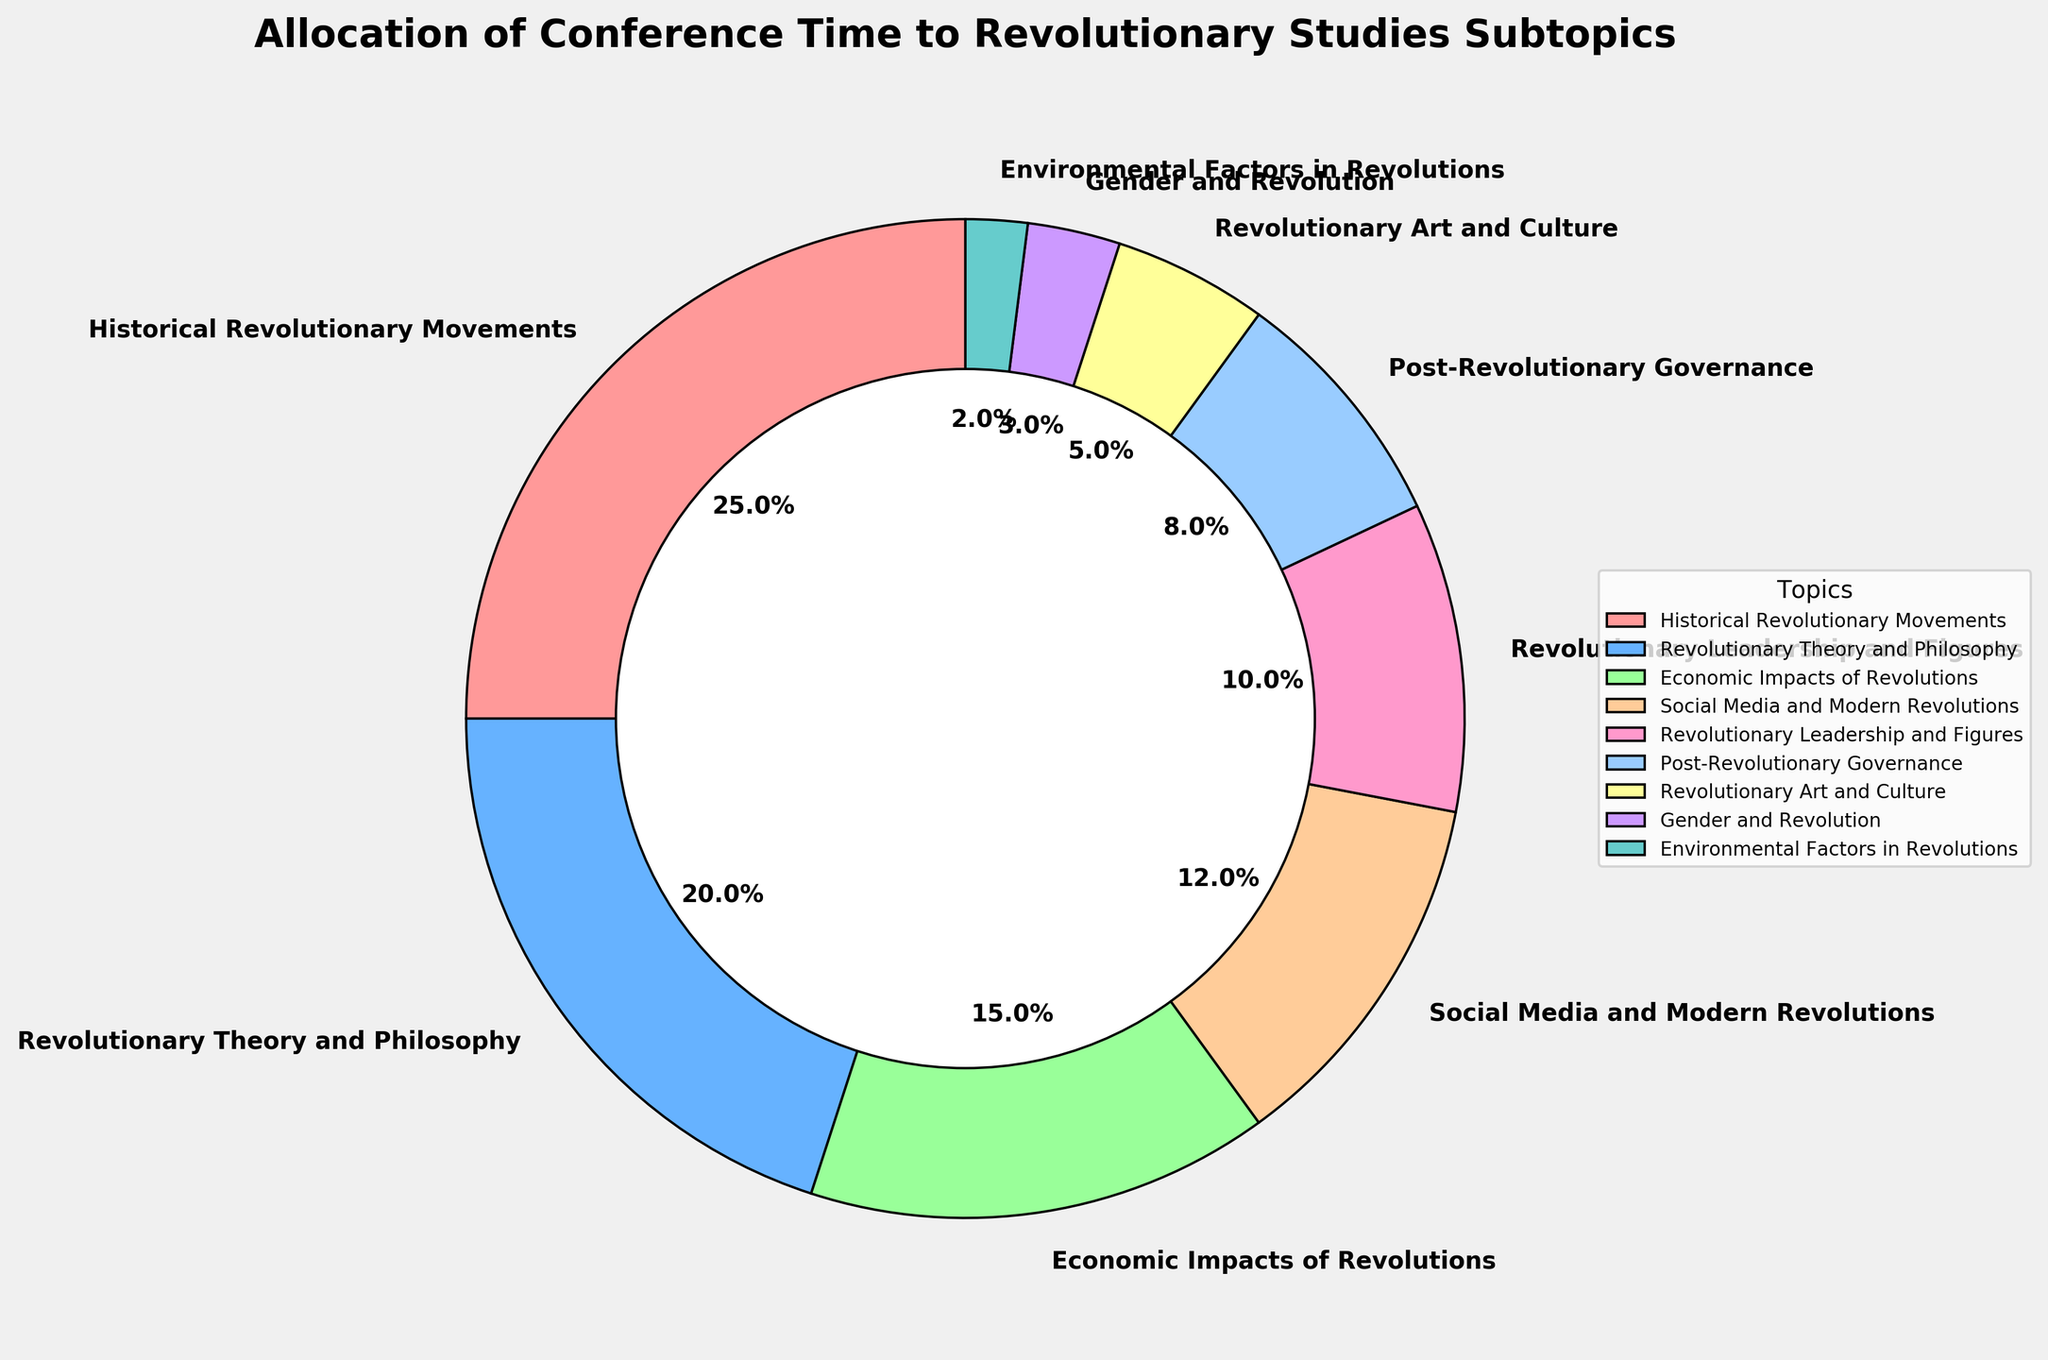what is the total percentage allocated to Historical Revolutionary Movements and Revolutionary Theory and Philosophy, combined? Add the percentages for Historical Revolutionary Movements (25%) and Revolutionary Theory and Philosophy (20%): 25 + 20 = 45
Answer: 45 Which subtopic receives the least amount of time in the conference's schedule? The smallest slice in the pie chart corresponds to Environmental Factors in Revolutions with 2%
Answer: Environmental Factors in Revolutions How does the time allocated to Economic Impacts of Revolutions compare to that for Revolutionary Leadership and Figures? The pie chart shows that Economic Impacts of Revolutions get 15%, and Revolutionary Leadership and Figures get 10%. Thus, Economic Impacts of Revolutions has 5% more time allocated (15 - 10 = 5)
Answer: Economic Impacts of Revolutions has 5% more What is the midpoint value of the percentages allocated to Post-Revolutionary Governance, Revolutionary Art and Culture, and Economic Impacts of Revolutions? First, sum the percentage values: 8 (Post-Revolutionary Governance) + 5 (Revolutionary Art and Culture) + 15 (Economic Impacts of Revolutions) = 28. Then divide by 3 for the average: 28 / 3 ≈ 9.33
Answer: 9.33 Which subtopics combined make up more than half (50%) of the conference's schedule? Combine the highest percentage subtopics until their total exceeds 50%. Adding Historical Revolutionary Movements (25%), Revolutionary Theory and Philosophy (20%), and Economic Impacts of Revolutions (15%) gives us a total of 60% (25 + 20 + 15 = 60)
Answer: Historical Revolutionary Movements, Revolutionary Theory and Philosophy, and Economic Impacts of Revolutions What is the difference in percentage allocation between Social Media and Modern Revolutions and Gender and Revolution? Social Media and Modern Revolutions are allocated 12%, and Gender and Revolution is allocated 3%. The difference is: 12 - 3 = 9
Answer: 9 Which subtopic related to leadership has the highest allocation percentage? Among the subtopics related to leadership, Revolutionary Leadership and Figures have the highest allocation at 10%
Answer: Revolutionary Leadership and Figures How much time is allocated to the combination of subtopics focusing on culture and gender aspects of revolutions (Revolutionary Art and Culture, and Gender and Revolution)? Add the percentages for Revolutionary Art and Culture (5%) and Gender and Revolution (3%): 5 + 3 = 8
Answer: 8 